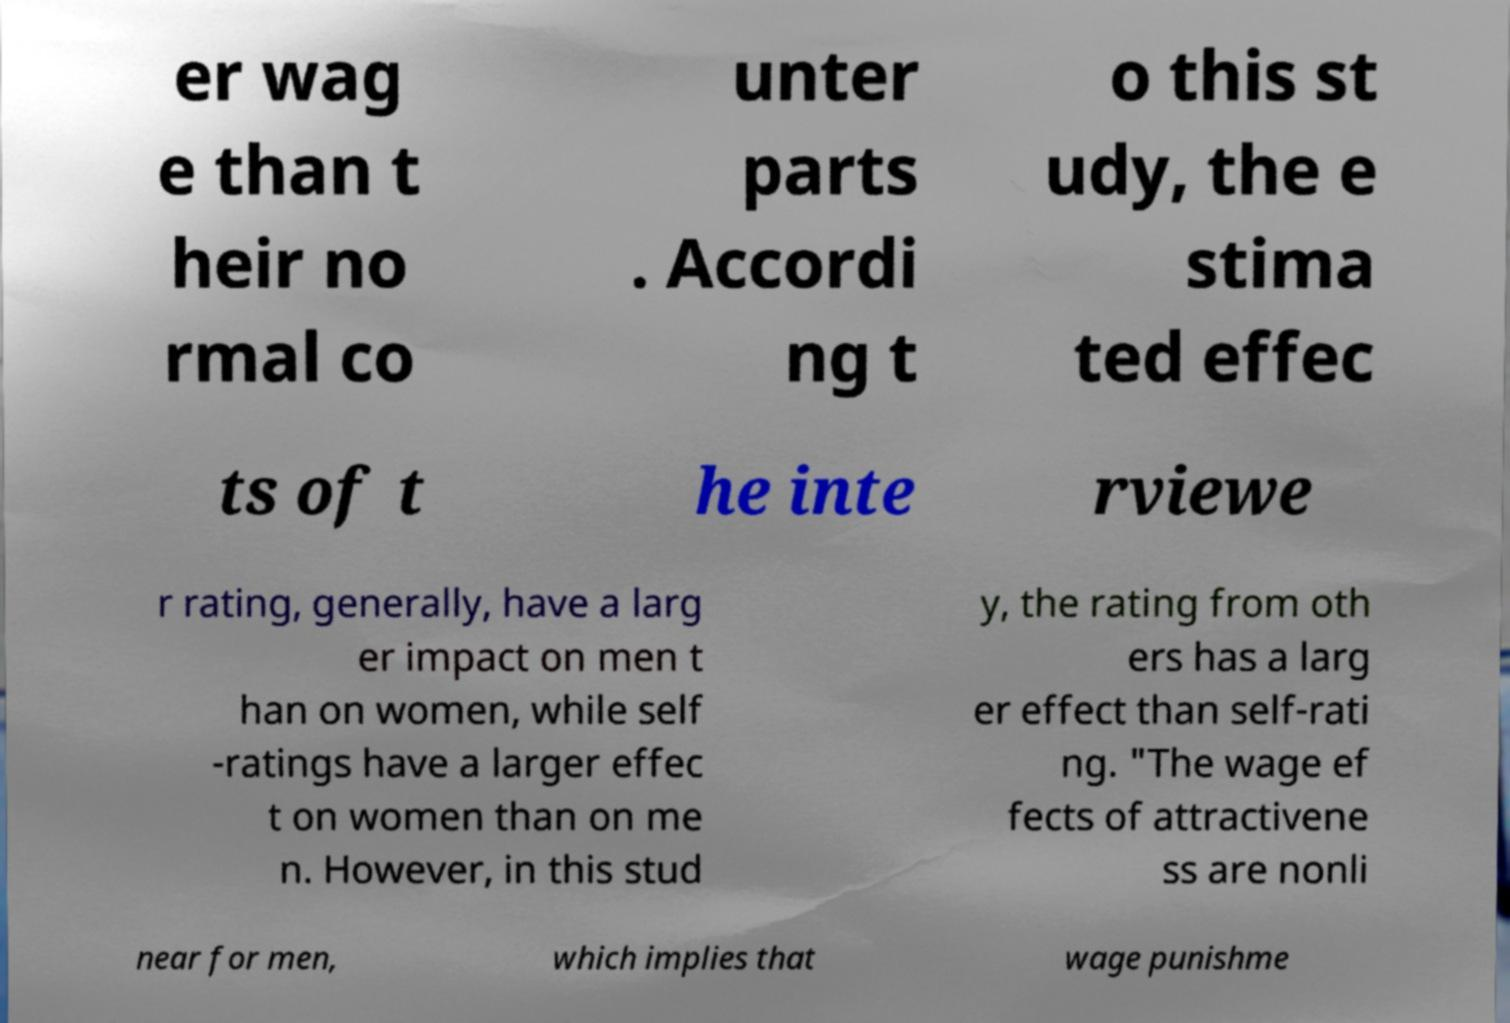There's text embedded in this image that I need extracted. Can you transcribe it verbatim? er wag e than t heir no rmal co unter parts . Accordi ng t o this st udy, the e stima ted effec ts of t he inte rviewe r rating, generally, have a larg er impact on men t han on women, while self -ratings have a larger effec t on women than on me n. However, in this stud y, the rating from oth ers has a larg er effect than self-rati ng. "The wage ef fects of attractivene ss are nonli near for men, which implies that wage punishme 